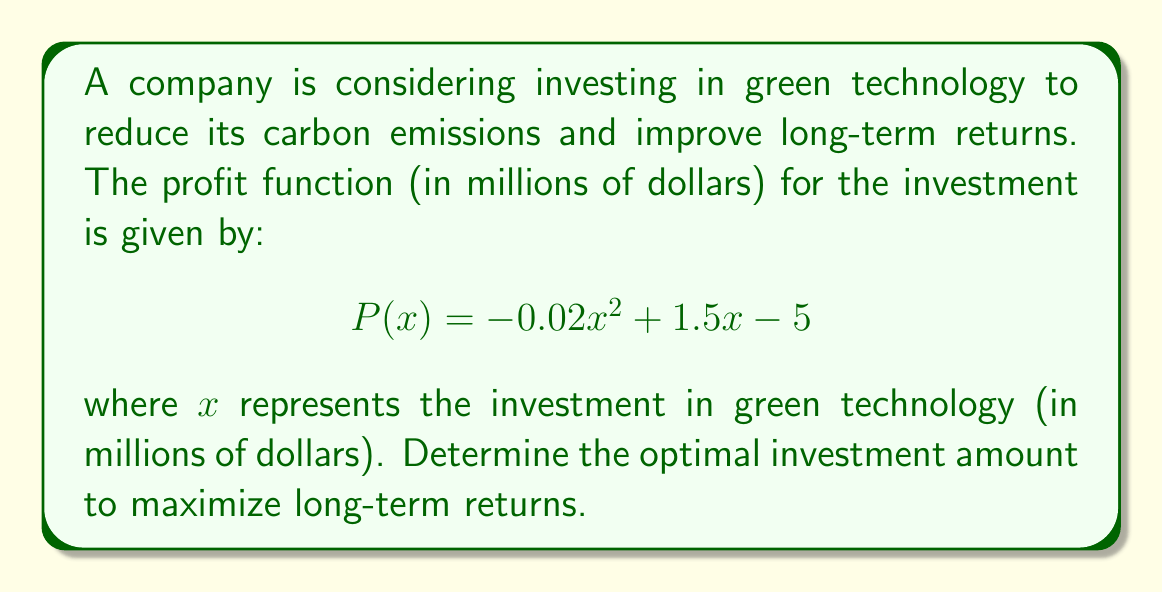What is the answer to this math problem? To find the optimal investment amount, we need to find the maximum of the profit function $P(x)$. This can be done by finding the value of $x$ where the derivative of $P(x)$ equals zero.

Step 1: Find the derivative of $P(x)$
$$P'(x) = \frac{d}{dx}(-0.02x^2 + 1.5x - 5)$$
$$P'(x) = -0.04x + 1.5$$

Step 2: Set the derivative equal to zero and solve for $x$
$$P'(x) = 0$$
$$-0.04x + 1.5 = 0$$
$$-0.04x = -1.5$$
$$x = \frac{-1.5}{-0.04} = 37.5$$

Step 3: Verify that this critical point is a maximum
The second derivative of $P(x)$ is:
$$P''(x) = -0.04$$
Since $P''(x)$ is negative for all $x$, the critical point is a maximum.

Step 4: Calculate the maximum profit
$$P(37.5) = -0.02(37.5)^2 + 1.5(37.5) - 5$$
$$= -28.125 + 56.25 - 5 = 23.125$$

Therefore, the optimal investment in green technology is $37.5 million, which will yield a maximum profit of $23.125 million.
Answer: $37.5 million 